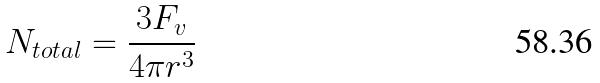<formula> <loc_0><loc_0><loc_500><loc_500>N _ { t o t a l } = \frac { 3 F _ { v } } { 4 \pi r ^ { 3 } }</formula> 